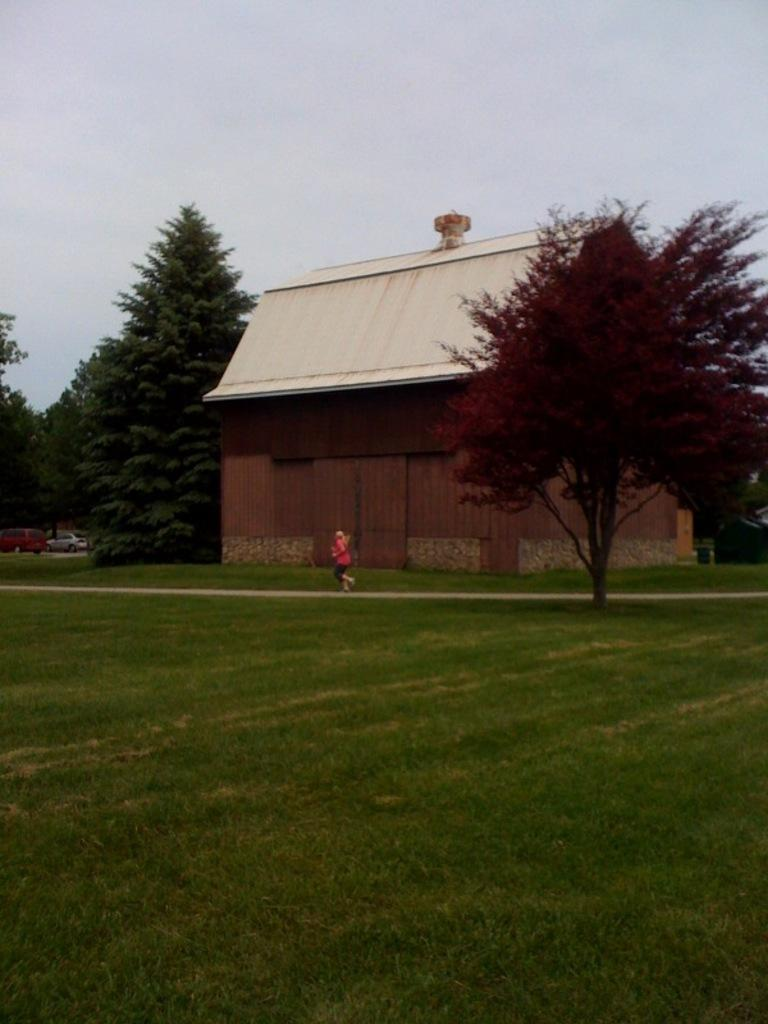What is the person in the image doing? The person is running in the image. On what surface is the person running? The person is running on the ground. What can be seen in the background of the image? There are trees, a building, grass, and sky visible in the background of the image. Are there any other objects present in the background of the image? Yes, there are other objects in the background of the image. What book is the person comparing in the image? There is no book present in the image; it features a person running on the ground. What is the person's middle name in the image? There is no information about the person's name in the image, so it cannot be determined. 